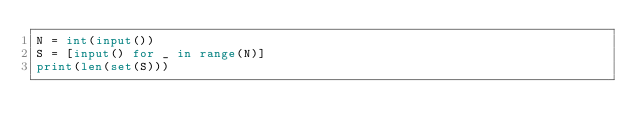Convert code to text. <code><loc_0><loc_0><loc_500><loc_500><_Python_>N = int(input())
S = [input() for _ in range(N)]
print(len(set(S)))</code> 